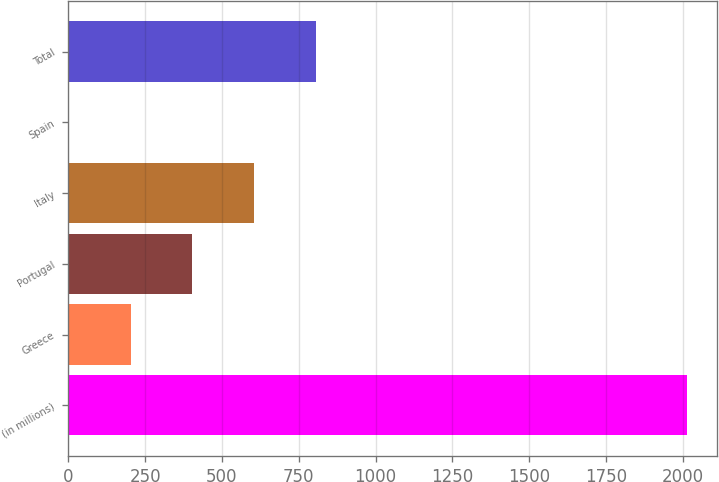Convert chart. <chart><loc_0><loc_0><loc_500><loc_500><bar_chart><fcel>(in millions)<fcel>Greece<fcel>Portugal<fcel>Italy<fcel>Spain<fcel>Total<nl><fcel>2012<fcel>203<fcel>404<fcel>605<fcel>2<fcel>806<nl></chart> 